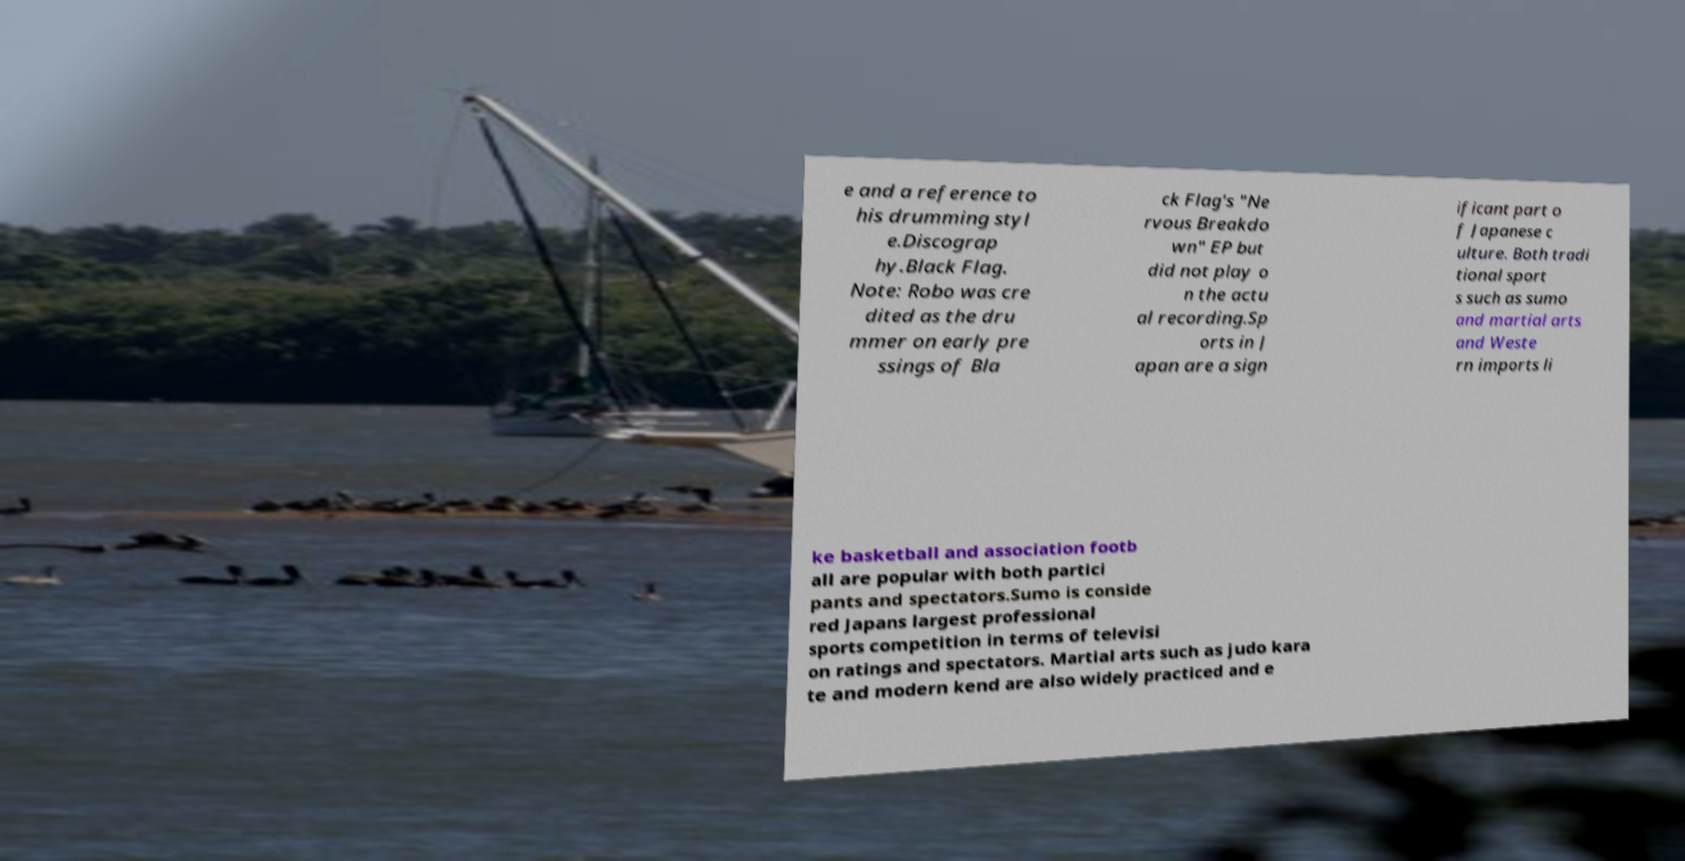I need the written content from this picture converted into text. Can you do that? e and a reference to his drumming styl e.Discograp hy.Black Flag. Note: Robo was cre dited as the dru mmer on early pre ssings of Bla ck Flag's "Ne rvous Breakdo wn" EP but did not play o n the actu al recording.Sp orts in J apan are a sign ificant part o f Japanese c ulture. Both tradi tional sport s such as sumo and martial arts and Weste rn imports li ke basketball and association footb all are popular with both partici pants and spectators.Sumo is conside red Japans largest professional sports competition in terms of televisi on ratings and spectators. Martial arts such as judo kara te and modern kend are also widely practiced and e 